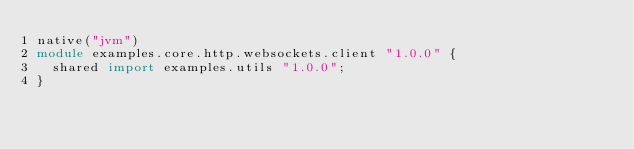Convert code to text. <code><loc_0><loc_0><loc_500><loc_500><_Ceylon_>native("jvm")
module examples.core.http.websockets.client "1.0.0" {
  shared import examples.utils "1.0.0";
}
</code> 